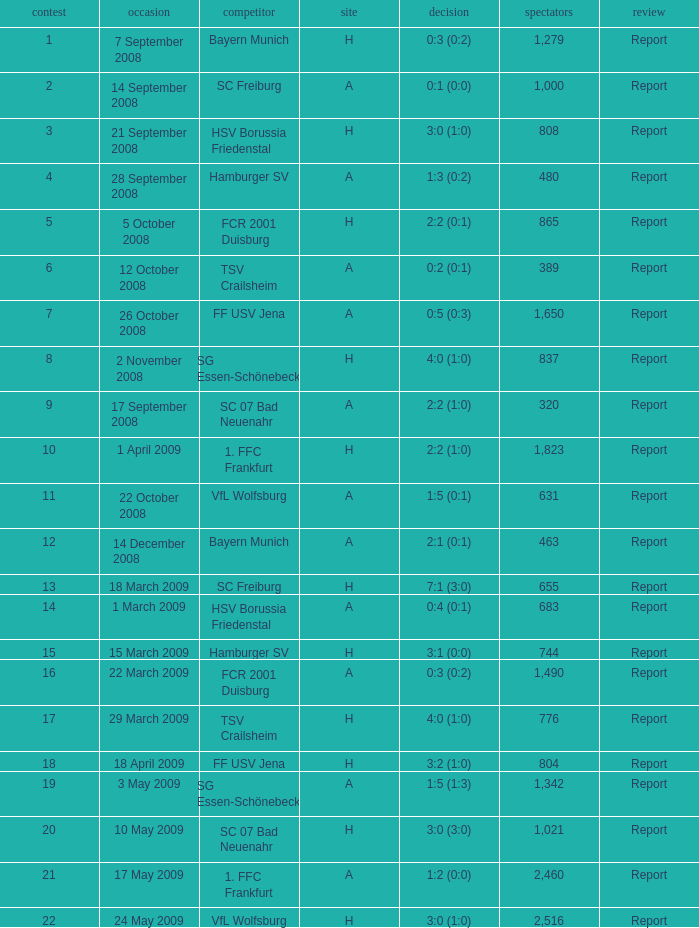Which match did FCR 2001 Duisburg participate as the opponent? 21.0. 